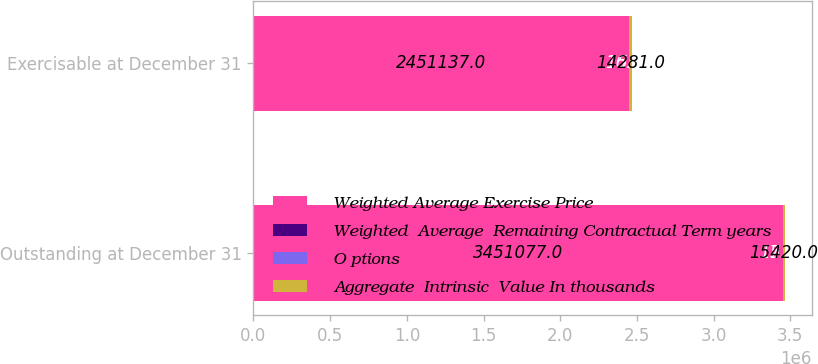Convert chart to OTSL. <chart><loc_0><loc_0><loc_500><loc_500><stacked_bar_chart><ecel><fcel>Outstanding at December 31<fcel>Exercisable at December 31<nl><fcel>Weighted Average Exercise Price<fcel>3.45108e+06<fcel>2.45114e+06<nl><fcel>Weighted  Average  Remaining Contractual Term years<fcel>17.96<fcel>16.51<nl><fcel>O ptions<fcel>5.5<fcel>5.1<nl><fcel>Aggregate  Intrinsic  Value In thousands<fcel>15420<fcel>14281<nl></chart> 